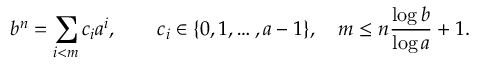Convert formula to latex. <formula><loc_0><loc_0><loc_500><loc_500>b ^ { n } = \sum _ { i < m } c _ { i } a ^ { i } , \quad c _ { i } \in \{ 0 , 1 , \dots , a - 1 \} , \quad m \leq n { \frac { \log b } { \log a } } + 1 .</formula> 